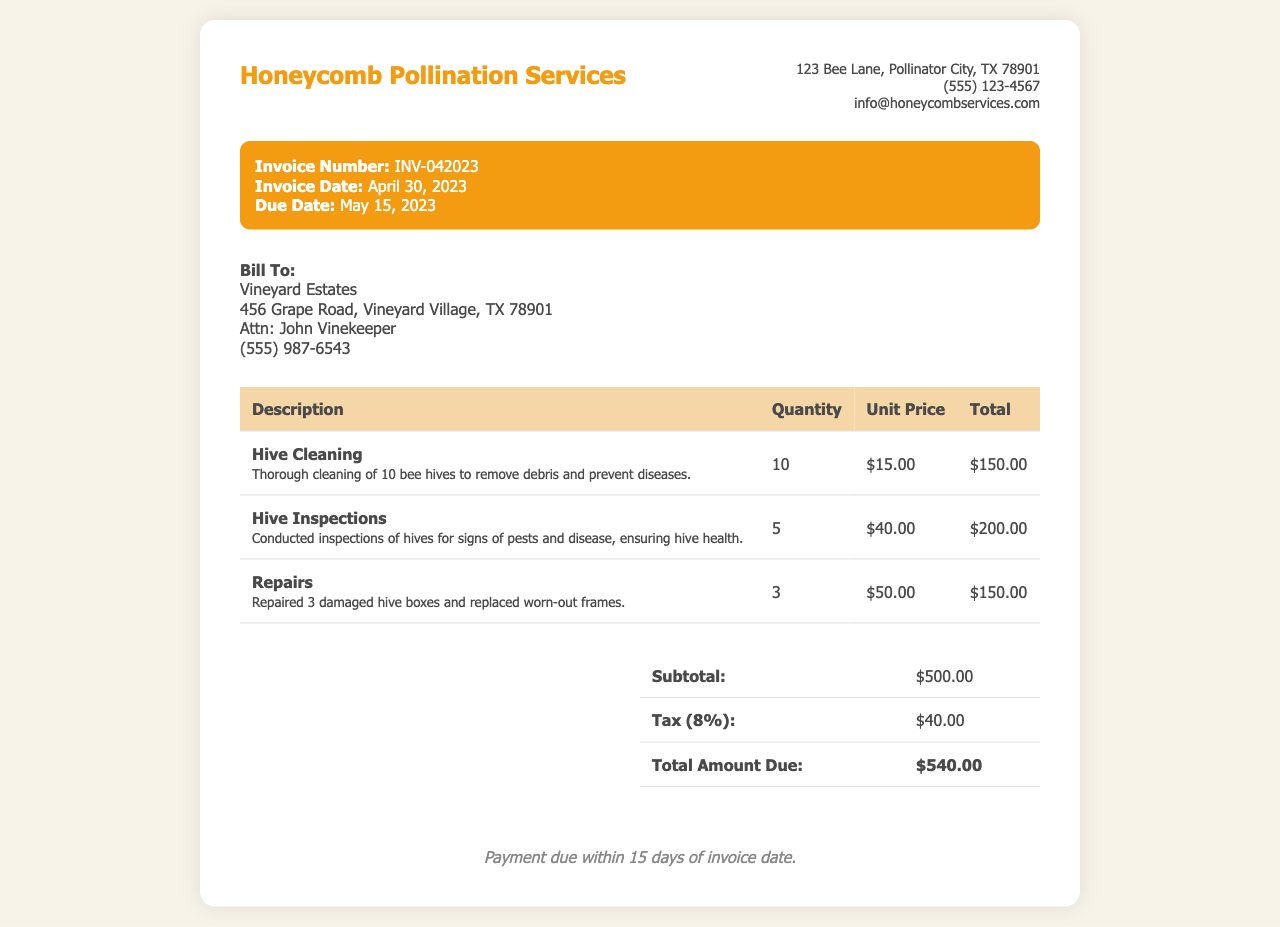What is the invoice number? The invoice number is mentioned in the invoice details section, which shows INV-042023.
Answer: INV-042023 What is the due date for the invoice? The due date is specified in the invoice details section, which states May 15, 2023.
Answer: May 15, 2023 How many hives were cleaned? The description of hive cleaning indicates that a thorough cleaning of 10 bee hives was performed.
Answer: 10 What was the total amount due? The total amount due is listed in the summary section of the invoice, which shows $540.00.
Answer: $540.00 What is the service for the unit price of $50.00? The unit price of $50.00 corresponds to the repairs mentioned in the invoice.
Answer: Repairs What percentage is the tax applied? The tax is calculated as 8%, as stated in the summary table.
Answer: 8% What condition was inspected in the hives? The hive inspections were conducted for signs of pests and disease, ensuring hive health.
Answer: Pests and disease What does the payment terms specify? The payment terms state that payment is due within 15 days of the invoice date.
Answer: 15 days How many hive inspections were conducted? The invoice specifies that 5 hive inspections were conducted.
Answer: 5 